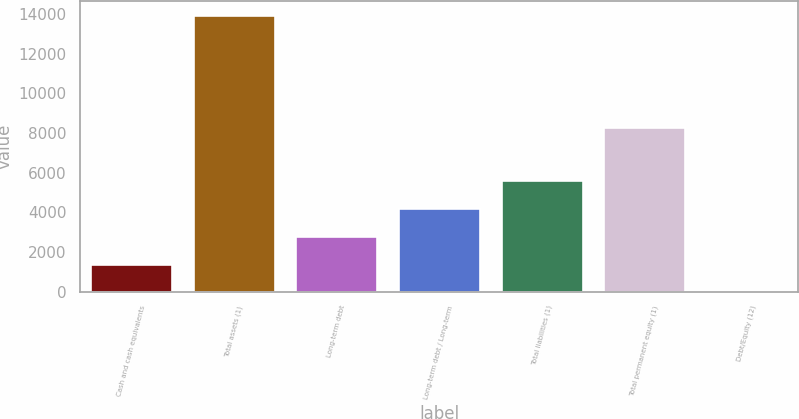Convert chart. <chart><loc_0><loc_0><loc_500><loc_500><bar_chart><fcel>Cash and cash equivalents<fcel>Total assets (1)<fcel>Long-term debt<fcel>Long-term debt / Long-term<fcel>Total liabilities (1)<fcel>Total permanent equity (1)<fcel>Debt/Equity (12)<nl><fcel>1410.99<fcel>13938.9<fcel>2802.98<fcel>4194.97<fcel>5636<fcel>8302.9<fcel>19<nl></chart> 